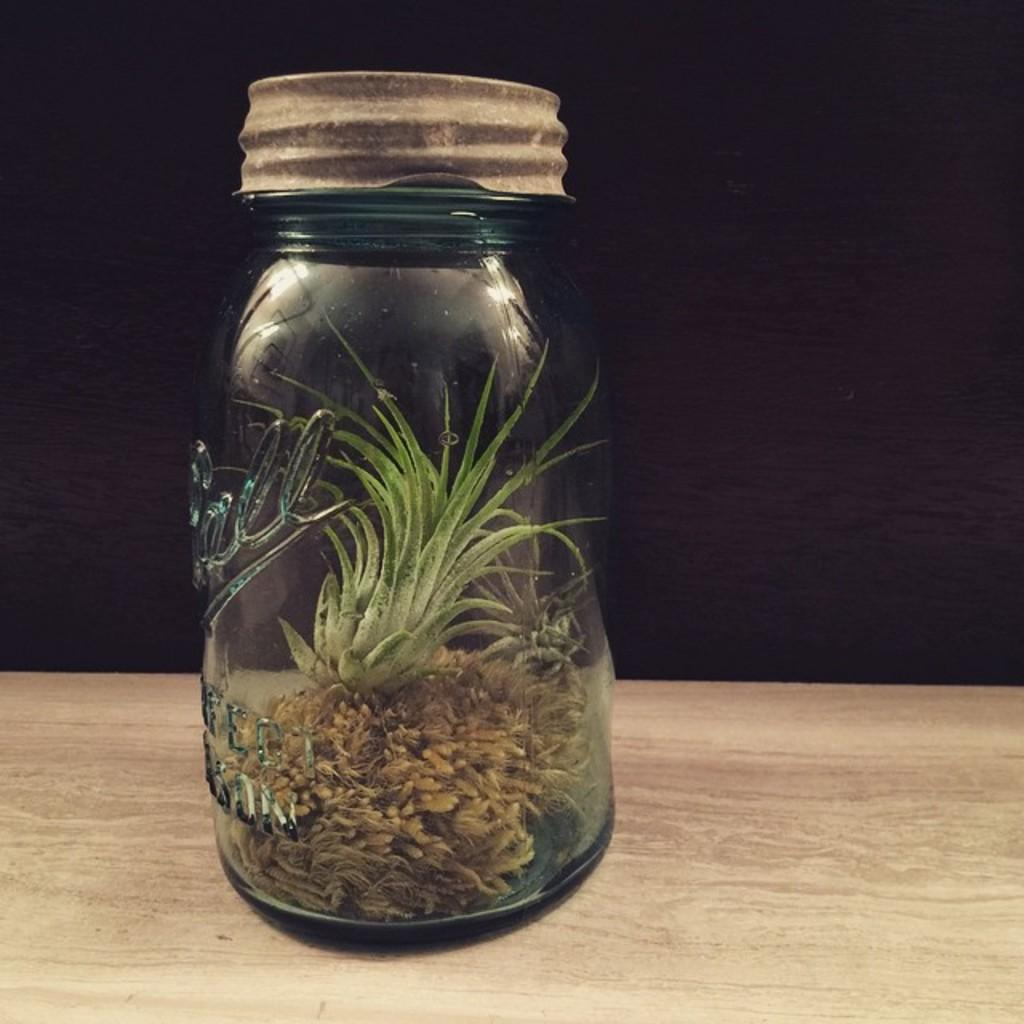What is inside the jar that is visible in the image? There are plants in a jar. Where is the jar located in the image? The jar is placed on a wooden surface. What shelf is the jar placed on in the image? There is no shelf mentioned in the image; the jar is placed on a wooden surface. What caused the plants to grow in the jar? The image does not provide information about how the plants grew in the jar, so we cannot determine the cause from the image alone. 